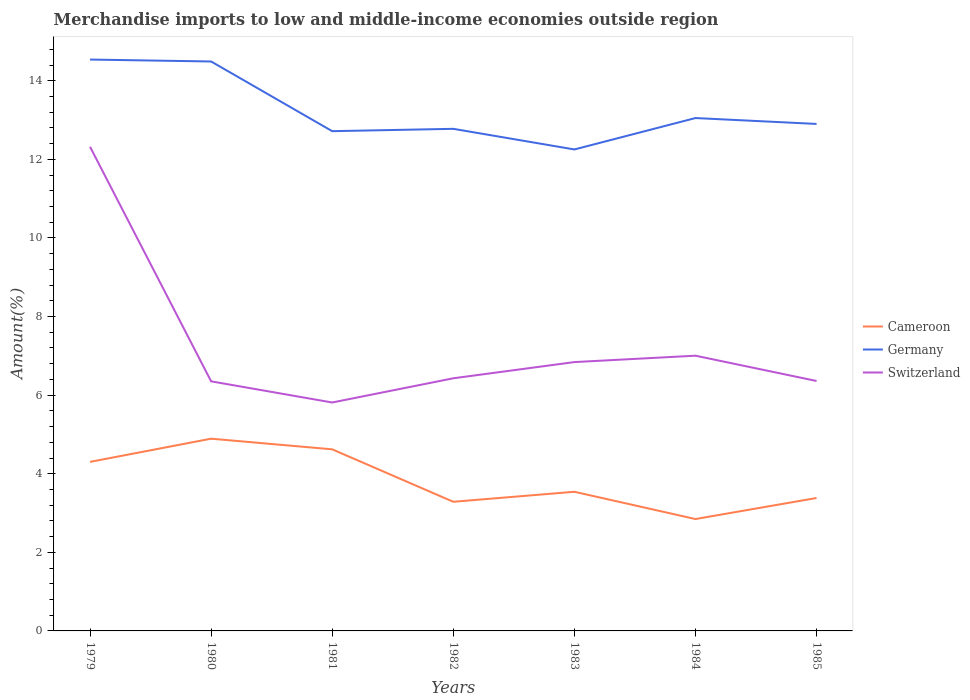Across all years, what is the maximum percentage of amount earned from merchandise imports in Switzerland?
Provide a short and direct response. 5.81. What is the total percentage of amount earned from merchandise imports in Germany in the graph?
Offer a terse response. -0.27. What is the difference between the highest and the second highest percentage of amount earned from merchandise imports in Switzerland?
Your answer should be very brief. 6.51. Is the percentage of amount earned from merchandise imports in Germany strictly greater than the percentage of amount earned from merchandise imports in Cameroon over the years?
Provide a short and direct response. No. What is the difference between two consecutive major ticks on the Y-axis?
Provide a short and direct response. 2. Does the graph contain grids?
Ensure brevity in your answer.  No. Where does the legend appear in the graph?
Keep it short and to the point. Center right. How are the legend labels stacked?
Your answer should be very brief. Vertical. What is the title of the graph?
Keep it short and to the point. Merchandise imports to low and middle-income economies outside region. What is the label or title of the X-axis?
Offer a very short reply. Years. What is the label or title of the Y-axis?
Ensure brevity in your answer.  Amount(%). What is the Amount(%) of Cameroon in 1979?
Ensure brevity in your answer.  4.3. What is the Amount(%) in Germany in 1979?
Make the answer very short. 14.54. What is the Amount(%) of Switzerland in 1979?
Keep it short and to the point. 12.32. What is the Amount(%) in Cameroon in 1980?
Ensure brevity in your answer.  4.89. What is the Amount(%) of Germany in 1980?
Ensure brevity in your answer.  14.49. What is the Amount(%) of Switzerland in 1980?
Offer a terse response. 6.35. What is the Amount(%) in Cameroon in 1981?
Your answer should be very brief. 4.62. What is the Amount(%) of Germany in 1981?
Your response must be concise. 12.72. What is the Amount(%) of Switzerland in 1981?
Your answer should be very brief. 5.81. What is the Amount(%) of Cameroon in 1982?
Make the answer very short. 3.29. What is the Amount(%) of Germany in 1982?
Your answer should be very brief. 12.78. What is the Amount(%) of Switzerland in 1982?
Your answer should be compact. 6.43. What is the Amount(%) in Cameroon in 1983?
Provide a short and direct response. 3.54. What is the Amount(%) of Germany in 1983?
Ensure brevity in your answer.  12.25. What is the Amount(%) of Switzerland in 1983?
Your answer should be very brief. 6.84. What is the Amount(%) in Cameroon in 1984?
Make the answer very short. 2.85. What is the Amount(%) of Germany in 1984?
Your response must be concise. 13.05. What is the Amount(%) in Switzerland in 1984?
Your response must be concise. 7. What is the Amount(%) of Cameroon in 1985?
Provide a short and direct response. 3.38. What is the Amount(%) of Germany in 1985?
Offer a terse response. 12.9. What is the Amount(%) in Switzerland in 1985?
Offer a terse response. 6.36. Across all years, what is the maximum Amount(%) in Cameroon?
Give a very brief answer. 4.89. Across all years, what is the maximum Amount(%) of Germany?
Your response must be concise. 14.54. Across all years, what is the maximum Amount(%) in Switzerland?
Give a very brief answer. 12.32. Across all years, what is the minimum Amount(%) of Cameroon?
Offer a terse response. 2.85. Across all years, what is the minimum Amount(%) of Germany?
Ensure brevity in your answer.  12.25. Across all years, what is the minimum Amount(%) of Switzerland?
Provide a succinct answer. 5.81. What is the total Amount(%) in Cameroon in the graph?
Keep it short and to the point. 26.87. What is the total Amount(%) of Germany in the graph?
Your answer should be compact. 92.73. What is the total Amount(%) in Switzerland in the graph?
Your answer should be very brief. 51.12. What is the difference between the Amount(%) in Cameroon in 1979 and that in 1980?
Provide a succinct answer. -0.59. What is the difference between the Amount(%) in Germany in 1979 and that in 1980?
Your response must be concise. 0.05. What is the difference between the Amount(%) in Switzerland in 1979 and that in 1980?
Make the answer very short. 5.97. What is the difference between the Amount(%) of Cameroon in 1979 and that in 1981?
Keep it short and to the point. -0.32. What is the difference between the Amount(%) of Germany in 1979 and that in 1981?
Make the answer very short. 1.82. What is the difference between the Amount(%) of Switzerland in 1979 and that in 1981?
Give a very brief answer. 6.51. What is the difference between the Amount(%) in Cameroon in 1979 and that in 1982?
Offer a terse response. 1.02. What is the difference between the Amount(%) of Germany in 1979 and that in 1982?
Offer a terse response. 1.76. What is the difference between the Amount(%) in Switzerland in 1979 and that in 1982?
Provide a short and direct response. 5.89. What is the difference between the Amount(%) of Cameroon in 1979 and that in 1983?
Ensure brevity in your answer.  0.76. What is the difference between the Amount(%) in Germany in 1979 and that in 1983?
Make the answer very short. 2.29. What is the difference between the Amount(%) in Switzerland in 1979 and that in 1983?
Offer a very short reply. 5.48. What is the difference between the Amount(%) in Cameroon in 1979 and that in 1984?
Your answer should be compact. 1.45. What is the difference between the Amount(%) in Germany in 1979 and that in 1984?
Offer a very short reply. 1.49. What is the difference between the Amount(%) in Switzerland in 1979 and that in 1984?
Offer a terse response. 5.32. What is the difference between the Amount(%) of Cameroon in 1979 and that in 1985?
Keep it short and to the point. 0.92. What is the difference between the Amount(%) in Germany in 1979 and that in 1985?
Your answer should be very brief. 1.64. What is the difference between the Amount(%) in Switzerland in 1979 and that in 1985?
Your answer should be compact. 5.96. What is the difference between the Amount(%) of Cameroon in 1980 and that in 1981?
Ensure brevity in your answer.  0.27. What is the difference between the Amount(%) in Germany in 1980 and that in 1981?
Keep it short and to the point. 1.77. What is the difference between the Amount(%) in Switzerland in 1980 and that in 1981?
Your answer should be very brief. 0.54. What is the difference between the Amount(%) of Cameroon in 1980 and that in 1982?
Your answer should be compact. 1.61. What is the difference between the Amount(%) of Germany in 1980 and that in 1982?
Provide a short and direct response. 1.71. What is the difference between the Amount(%) of Switzerland in 1980 and that in 1982?
Your response must be concise. -0.08. What is the difference between the Amount(%) in Cameroon in 1980 and that in 1983?
Ensure brevity in your answer.  1.35. What is the difference between the Amount(%) of Germany in 1980 and that in 1983?
Your answer should be very brief. 2.24. What is the difference between the Amount(%) of Switzerland in 1980 and that in 1983?
Offer a very short reply. -0.49. What is the difference between the Amount(%) of Cameroon in 1980 and that in 1984?
Provide a succinct answer. 2.04. What is the difference between the Amount(%) of Germany in 1980 and that in 1984?
Your answer should be compact. 1.44. What is the difference between the Amount(%) in Switzerland in 1980 and that in 1984?
Give a very brief answer. -0.65. What is the difference between the Amount(%) in Cameroon in 1980 and that in 1985?
Keep it short and to the point. 1.51. What is the difference between the Amount(%) of Germany in 1980 and that in 1985?
Your answer should be very brief. 1.59. What is the difference between the Amount(%) of Switzerland in 1980 and that in 1985?
Give a very brief answer. -0.01. What is the difference between the Amount(%) of Cameroon in 1981 and that in 1982?
Make the answer very short. 1.33. What is the difference between the Amount(%) in Germany in 1981 and that in 1982?
Your answer should be compact. -0.06. What is the difference between the Amount(%) of Switzerland in 1981 and that in 1982?
Keep it short and to the point. -0.62. What is the difference between the Amount(%) in Cameroon in 1981 and that in 1983?
Make the answer very short. 1.08. What is the difference between the Amount(%) of Germany in 1981 and that in 1983?
Provide a succinct answer. 0.47. What is the difference between the Amount(%) of Switzerland in 1981 and that in 1983?
Your response must be concise. -1.03. What is the difference between the Amount(%) in Cameroon in 1981 and that in 1984?
Offer a terse response. 1.77. What is the difference between the Amount(%) in Germany in 1981 and that in 1984?
Your answer should be compact. -0.33. What is the difference between the Amount(%) of Switzerland in 1981 and that in 1984?
Offer a very short reply. -1.19. What is the difference between the Amount(%) in Cameroon in 1981 and that in 1985?
Provide a succinct answer. 1.24. What is the difference between the Amount(%) of Germany in 1981 and that in 1985?
Your response must be concise. -0.18. What is the difference between the Amount(%) of Switzerland in 1981 and that in 1985?
Offer a terse response. -0.55. What is the difference between the Amount(%) of Cameroon in 1982 and that in 1983?
Your answer should be very brief. -0.25. What is the difference between the Amount(%) in Germany in 1982 and that in 1983?
Your answer should be very brief. 0.52. What is the difference between the Amount(%) of Switzerland in 1982 and that in 1983?
Ensure brevity in your answer.  -0.41. What is the difference between the Amount(%) of Cameroon in 1982 and that in 1984?
Your answer should be very brief. 0.44. What is the difference between the Amount(%) of Germany in 1982 and that in 1984?
Your answer should be compact. -0.27. What is the difference between the Amount(%) of Switzerland in 1982 and that in 1984?
Keep it short and to the point. -0.57. What is the difference between the Amount(%) of Cameroon in 1982 and that in 1985?
Ensure brevity in your answer.  -0.1. What is the difference between the Amount(%) in Germany in 1982 and that in 1985?
Your answer should be compact. -0.12. What is the difference between the Amount(%) in Switzerland in 1982 and that in 1985?
Ensure brevity in your answer.  0.07. What is the difference between the Amount(%) in Cameroon in 1983 and that in 1984?
Offer a terse response. 0.69. What is the difference between the Amount(%) in Germany in 1983 and that in 1984?
Offer a very short reply. -0.8. What is the difference between the Amount(%) of Switzerland in 1983 and that in 1984?
Give a very brief answer. -0.16. What is the difference between the Amount(%) in Cameroon in 1983 and that in 1985?
Offer a very short reply. 0.16. What is the difference between the Amount(%) of Germany in 1983 and that in 1985?
Offer a very short reply. -0.65. What is the difference between the Amount(%) of Switzerland in 1983 and that in 1985?
Ensure brevity in your answer.  0.48. What is the difference between the Amount(%) in Cameroon in 1984 and that in 1985?
Provide a succinct answer. -0.54. What is the difference between the Amount(%) of Germany in 1984 and that in 1985?
Provide a succinct answer. 0.15. What is the difference between the Amount(%) of Switzerland in 1984 and that in 1985?
Provide a short and direct response. 0.64. What is the difference between the Amount(%) of Cameroon in 1979 and the Amount(%) of Germany in 1980?
Keep it short and to the point. -10.19. What is the difference between the Amount(%) of Cameroon in 1979 and the Amount(%) of Switzerland in 1980?
Provide a short and direct response. -2.05. What is the difference between the Amount(%) of Germany in 1979 and the Amount(%) of Switzerland in 1980?
Make the answer very short. 8.19. What is the difference between the Amount(%) of Cameroon in 1979 and the Amount(%) of Germany in 1981?
Keep it short and to the point. -8.42. What is the difference between the Amount(%) in Cameroon in 1979 and the Amount(%) in Switzerland in 1981?
Offer a terse response. -1.51. What is the difference between the Amount(%) of Germany in 1979 and the Amount(%) of Switzerland in 1981?
Give a very brief answer. 8.73. What is the difference between the Amount(%) of Cameroon in 1979 and the Amount(%) of Germany in 1982?
Keep it short and to the point. -8.47. What is the difference between the Amount(%) in Cameroon in 1979 and the Amount(%) in Switzerland in 1982?
Your response must be concise. -2.13. What is the difference between the Amount(%) in Germany in 1979 and the Amount(%) in Switzerland in 1982?
Give a very brief answer. 8.11. What is the difference between the Amount(%) in Cameroon in 1979 and the Amount(%) in Germany in 1983?
Provide a succinct answer. -7.95. What is the difference between the Amount(%) of Cameroon in 1979 and the Amount(%) of Switzerland in 1983?
Offer a very short reply. -2.54. What is the difference between the Amount(%) in Germany in 1979 and the Amount(%) in Switzerland in 1983?
Ensure brevity in your answer.  7.7. What is the difference between the Amount(%) in Cameroon in 1979 and the Amount(%) in Germany in 1984?
Offer a very short reply. -8.75. What is the difference between the Amount(%) in Cameroon in 1979 and the Amount(%) in Switzerland in 1984?
Your answer should be very brief. -2.7. What is the difference between the Amount(%) of Germany in 1979 and the Amount(%) of Switzerland in 1984?
Provide a succinct answer. 7.54. What is the difference between the Amount(%) of Cameroon in 1979 and the Amount(%) of Germany in 1985?
Ensure brevity in your answer.  -8.6. What is the difference between the Amount(%) of Cameroon in 1979 and the Amount(%) of Switzerland in 1985?
Offer a very short reply. -2.06. What is the difference between the Amount(%) in Germany in 1979 and the Amount(%) in Switzerland in 1985?
Your answer should be compact. 8.18. What is the difference between the Amount(%) in Cameroon in 1980 and the Amount(%) in Germany in 1981?
Keep it short and to the point. -7.83. What is the difference between the Amount(%) of Cameroon in 1980 and the Amount(%) of Switzerland in 1981?
Provide a short and direct response. -0.92. What is the difference between the Amount(%) in Germany in 1980 and the Amount(%) in Switzerland in 1981?
Provide a short and direct response. 8.68. What is the difference between the Amount(%) of Cameroon in 1980 and the Amount(%) of Germany in 1982?
Provide a short and direct response. -7.89. What is the difference between the Amount(%) of Cameroon in 1980 and the Amount(%) of Switzerland in 1982?
Provide a short and direct response. -1.54. What is the difference between the Amount(%) of Germany in 1980 and the Amount(%) of Switzerland in 1982?
Make the answer very short. 8.06. What is the difference between the Amount(%) of Cameroon in 1980 and the Amount(%) of Germany in 1983?
Your answer should be very brief. -7.36. What is the difference between the Amount(%) of Cameroon in 1980 and the Amount(%) of Switzerland in 1983?
Your answer should be very brief. -1.95. What is the difference between the Amount(%) of Germany in 1980 and the Amount(%) of Switzerland in 1983?
Keep it short and to the point. 7.65. What is the difference between the Amount(%) of Cameroon in 1980 and the Amount(%) of Germany in 1984?
Keep it short and to the point. -8.16. What is the difference between the Amount(%) in Cameroon in 1980 and the Amount(%) in Switzerland in 1984?
Give a very brief answer. -2.11. What is the difference between the Amount(%) of Germany in 1980 and the Amount(%) of Switzerland in 1984?
Ensure brevity in your answer.  7.49. What is the difference between the Amount(%) in Cameroon in 1980 and the Amount(%) in Germany in 1985?
Keep it short and to the point. -8.01. What is the difference between the Amount(%) of Cameroon in 1980 and the Amount(%) of Switzerland in 1985?
Your answer should be very brief. -1.47. What is the difference between the Amount(%) in Germany in 1980 and the Amount(%) in Switzerland in 1985?
Your response must be concise. 8.13. What is the difference between the Amount(%) of Cameroon in 1981 and the Amount(%) of Germany in 1982?
Offer a very short reply. -8.16. What is the difference between the Amount(%) in Cameroon in 1981 and the Amount(%) in Switzerland in 1982?
Your answer should be compact. -1.81. What is the difference between the Amount(%) in Germany in 1981 and the Amount(%) in Switzerland in 1982?
Give a very brief answer. 6.29. What is the difference between the Amount(%) of Cameroon in 1981 and the Amount(%) of Germany in 1983?
Provide a short and direct response. -7.63. What is the difference between the Amount(%) in Cameroon in 1981 and the Amount(%) in Switzerland in 1983?
Offer a terse response. -2.22. What is the difference between the Amount(%) of Germany in 1981 and the Amount(%) of Switzerland in 1983?
Make the answer very short. 5.88. What is the difference between the Amount(%) in Cameroon in 1981 and the Amount(%) in Germany in 1984?
Provide a short and direct response. -8.43. What is the difference between the Amount(%) in Cameroon in 1981 and the Amount(%) in Switzerland in 1984?
Offer a very short reply. -2.38. What is the difference between the Amount(%) in Germany in 1981 and the Amount(%) in Switzerland in 1984?
Provide a short and direct response. 5.71. What is the difference between the Amount(%) of Cameroon in 1981 and the Amount(%) of Germany in 1985?
Offer a terse response. -8.28. What is the difference between the Amount(%) of Cameroon in 1981 and the Amount(%) of Switzerland in 1985?
Offer a very short reply. -1.74. What is the difference between the Amount(%) of Germany in 1981 and the Amount(%) of Switzerland in 1985?
Provide a succinct answer. 6.36. What is the difference between the Amount(%) of Cameroon in 1982 and the Amount(%) of Germany in 1983?
Provide a succinct answer. -8.97. What is the difference between the Amount(%) of Cameroon in 1982 and the Amount(%) of Switzerland in 1983?
Provide a succinct answer. -3.56. What is the difference between the Amount(%) of Germany in 1982 and the Amount(%) of Switzerland in 1983?
Offer a very short reply. 5.94. What is the difference between the Amount(%) of Cameroon in 1982 and the Amount(%) of Germany in 1984?
Ensure brevity in your answer.  -9.77. What is the difference between the Amount(%) of Cameroon in 1982 and the Amount(%) of Switzerland in 1984?
Keep it short and to the point. -3.72. What is the difference between the Amount(%) of Germany in 1982 and the Amount(%) of Switzerland in 1984?
Your answer should be compact. 5.77. What is the difference between the Amount(%) of Cameroon in 1982 and the Amount(%) of Germany in 1985?
Your answer should be compact. -9.62. What is the difference between the Amount(%) in Cameroon in 1982 and the Amount(%) in Switzerland in 1985?
Keep it short and to the point. -3.07. What is the difference between the Amount(%) of Germany in 1982 and the Amount(%) of Switzerland in 1985?
Provide a short and direct response. 6.42. What is the difference between the Amount(%) in Cameroon in 1983 and the Amount(%) in Germany in 1984?
Offer a terse response. -9.51. What is the difference between the Amount(%) in Cameroon in 1983 and the Amount(%) in Switzerland in 1984?
Your answer should be compact. -3.46. What is the difference between the Amount(%) of Germany in 1983 and the Amount(%) of Switzerland in 1984?
Offer a very short reply. 5.25. What is the difference between the Amount(%) of Cameroon in 1983 and the Amount(%) of Germany in 1985?
Keep it short and to the point. -9.36. What is the difference between the Amount(%) of Cameroon in 1983 and the Amount(%) of Switzerland in 1985?
Your answer should be compact. -2.82. What is the difference between the Amount(%) of Germany in 1983 and the Amount(%) of Switzerland in 1985?
Offer a terse response. 5.89. What is the difference between the Amount(%) of Cameroon in 1984 and the Amount(%) of Germany in 1985?
Keep it short and to the point. -10.05. What is the difference between the Amount(%) in Cameroon in 1984 and the Amount(%) in Switzerland in 1985?
Keep it short and to the point. -3.51. What is the difference between the Amount(%) in Germany in 1984 and the Amount(%) in Switzerland in 1985?
Ensure brevity in your answer.  6.69. What is the average Amount(%) of Cameroon per year?
Your answer should be compact. 3.84. What is the average Amount(%) in Germany per year?
Your answer should be compact. 13.25. What is the average Amount(%) in Switzerland per year?
Provide a succinct answer. 7.3. In the year 1979, what is the difference between the Amount(%) in Cameroon and Amount(%) in Germany?
Your response must be concise. -10.24. In the year 1979, what is the difference between the Amount(%) of Cameroon and Amount(%) of Switzerland?
Make the answer very short. -8.02. In the year 1979, what is the difference between the Amount(%) of Germany and Amount(%) of Switzerland?
Keep it short and to the point. 2.22. In the year 1980, what is the difference between the Amount(%) in Cameroon and Amount(%) in Germany?
Your response must be concise. -9.6. In the year 1980, what is the difference between the Amount(%) of Cameroon and Amount(%) of Switzerland?
Make the answer very short. -1.46. In the year 1980, what is the difference between the Amount(%) in Germany and Amount(%) in Switzerland?
Give a very brief answer. 8.14. In the year 1981, what is the difference between the Amount(%) of Cameroon and Amount(%) of Germany?
Your answer should be very brief. -8.1. In the year 1981, what is the difference between the Amount(%) in Cameroon and Amount(%) in Switzerland?
Provide a short and direct response. -1.19. In the year 1981, what is the difference between the Amount(%) in Germany and Amount(%) in Switzerland?
Ensure brevity in your answer.  6.9. In the year 1982, what is the difference between the Amount(%) of Cameroon and Amount(%) of Germany?
Your response must be concise. -9.49. In the year 1982, what is the difference between the Amount(%) of Cameroon and Amount(%) of Switzerland?
Make the answer very short. -3.14. In the year 1982, what is the difference between the Amount(%) in Germany and Amount(%) in Switzerland?
Your answer should be very brief. 6.35. In the year 1983, what is the difference between the Amount(%) in Cameroon and Amount(%) in Germany?
Offer a terse response. -8.71. In the year 1983, what is the difference between the Amount(%) in Cameroon and Amount(%) in Switzerland?
Offer a terse response. -3.3. In the year 1983, what is the difference between the Amount(%) of Germany and Amount(%) of Switzerland?
Offer a very short reply. 5.41. In the year 1984, what is the difference between the Amount(%) in Cameroon and Amount(%) in Germany?
Give a very brief answer. -10.2. In the year 1984, what is the difference between the Amount(%) in Cameroon and Amount(%) in Switzerland?
Keep it short and to the point. -4.16. In the year 1984, what is the difference between the Amount(%) of Germany and Amount(%) of Switzerland?
Your answer should be compact. 6.05. In the year 1985, what is the difference between the Amount(%) in Cameroon and Amount(%) in Germany?
Provide a succinct answer. -9.52. In the year 1985, what is the difference between the Amount(%) of Cameroon and Amount(%) of Switzerland?
Offer a terse response. -2.98. In the year 1985, what is the difference between the Amount(%) of Germany and Amount(%) of Switzerland?
Provide a succinct answer. 6.54. What is the ratio of the Amount(%) in Cameroon in 1979 to that in 1980?
Make the answer very short. 0.88. What is the ratio of the Amount(%) of Switzerland in 1979 to that in 1980?
Make the answer very short. 1.94. What is the ratio of the Amount(%) in Cameroon in 1979 to that in 1981?
Give a very brief answer. 0.93. What is the ratio of the Amount(%) in Germany in 1979 to that in 1981?
Offer a very short reply. 1.14. What is the ratio of the Amount(%) of Switzerland in 1979 to that in 1981?
Your answer should be compact. 2.12. What is the ratio of the Amount(%) of Cameroon in 1979 to that in 1982?
Keep it short and to the point. 1.31. What is the ratio of the Amount(%) in Germany in 1979 to that in 1982?
Ensure brevity in your answer.  1.14. What is the ratio of the Amount(%) of Switzerland in 1979 to that in 1982?
Your answer should be very brief. 1.92. What is the ratio of the Amount(%) of Cameroon in 1979 to that in 1983?
Offer a terse response. 1.21. What is the ratio of the Amount(%) of Germany in 1979 to that in 1983?
Give a very brief answer. 1.19. What is the ratio of the Amount(%) in Switzerland in 1979 to that in 1983?
Provide a succinct answer. 1.8. What is the ratio of the Amount(%) in Cameroon in 1979 to that in 1984?
Offer a terse response. 1.51. What is the ratio of the Amount(%) of Germany in 1979 to that in 1984?
Make the answer very short. 1.11. What is the ratio of the Amount(%) of Switzerland in 1979 to that in 1984?
Your answer should be very brief. 1.76. What is the ratio of the Amount(%) of Cameroon in 1979 to that in 1985?
Offer a very short reply. 1.27. What is the ratio of the Amount(%) of Germany in 1979 to that in 1985?
Your answer should be very brief. 1.13. What is the ratio of the Amount(%) of Switzerland in 1979 to that in 1985?
Your answer should be very brief. 1.94. What is the ratio of the Amount(%) of Cameroon in 1980 to that in 1981?
Your answer should be compact. 1.06. What is the ratio of the Amount(%) of Germany in 1980 to that in 1981?
Keep it short and to the point. 1.14. What is the ratio of the Amount(%) in Switzerland in 1980 to that in 1981?
Give a very brief answer. 1.09. What is the ratio of the Amount(%) in Cameroon in 1980 to that in 1982?
Your answer should be very brief. 1.49. What is the ratio of the Amount(%) of Germany in 1980 to that in 1982?
Provide a short and direct response. 1.13. What is the ratio of the Amount(%) in Switzerland in 1980 to that in 1982?
Offer a very short reply. 0.99. What is the ratio of the Amount(%) in Cameroon in 1980 to that in 1983?
Provide a succinct answer. 1.38. What is the ratio of the Amount(%) in Germany in 1980 to that in 1983?
Offer a terse response. 1.18. What is the ratio of the Amount(%) of Switzerland in 1980 to that in 1983?
Offer a terse response. 0.93. What is the ratio of the Amount(%) in Cameroon in 1980 to that in 1984?
Give a very brief answer. 1.72. What is the ratio of the Amount(%) in Germany in 1980 to that in 1984?
Provide a succinct answer. 1.11. What is the ratio of the Amount(%) in Switzerland in 1980 to that in 1984?
Keep it short and to the point. 0.91. What is the ratio of the Amount(%) in Cameroon in 1980 to that in 1985?
Ensure brevity in your answer.  1.45. What is the ratio of the Amount(%) of Germany in 1980 to that in 1985?
Your answer should be very brief. 1.12. What is the ratio of the Amount(%) of Switzerland in 1980 to that in 1985?
Your response must be concise. 1. What is the ratio of the Amount(%) in Cameroon in 1981 to that in 1982?
Keep it short and to the point. 1.41. What is the ratio of the Amount(%) in Switzerland in 1981 to that in 1982?
Your answer should be very brief. 0.9. What is the ratio of the Amount(%) in Cameroon in 1981 to that in 1983?
Ensure brevity in your answer.  1.31. What is the ratio of the Amount(%) of Germany in 1981 to that in 1983?
Offer a very short reply. 1.04. What is the ratio of the Amount(%) in Switzerland in 1981 to that in 1983?
Offer a terse response. 0.85. What is the ratio of the Amount(%) in Cameroon in 1981 to that in 1984?
Your answer should be compact. 1.62. What is the ratio of the Amount(%) of Germany in 1981 to that in 1984?
Your answer should be very brief. 0.97. What is the ratio of the Amount(%) of Switzerland in 1981 to that in 1984?
Your answer should be very brief. 0.83. What is the ratio of the Amount(%) of Cameroon in 1981 to that in 1985?
Make the answer very short. 1.37. What is the ratio of the Amount(%) of Germany in 1981 to that in 1985?
Ensure brevity in your answer.  0.99. What is the ratio of the Amount(%) in Switzerland in 1981 to that in 1985?
Make the answer very short. 0.91. What is the ratio of the Amount(%) of Cameroon in 1982 to that in 1983?
Your answer should be compact. 0.93. What is the ratio of the Amount(%) in Germany in 1982 to that in 1983?
Your answer should be compact. 1.04. What is the ratio of the Amount(%) in Switzerland in 1982 to that in 1983?
Give a very brief answer. 0.94. What is the ratio of the Amount(%) in Cameroon in 1982 to that in 1984?
Provide a succinct answer. 1.15. What is the ratio of the Amount(%) in Switzerland in 1982 to that in 1984?
Offer a very short reply. 0.92. What is the ratio of the Amount(%) of Cameroon in 1982 to that in 1985?
Provide a short and direct response. 0.97. What is the ratio of the Amount(%) of Germany in 1982 to that in 1985?
Offer a very short reply. 0.99. What is the ratio of the Amount(%) of Switzerland in 1982 to that in 1985?
Provide a short and direct response. 1.01. What is the ratio of the Amount(%) in Cameroon in 1983 to that in 1984?
Make the answer very short. 1.24. What is the ratio of the Amount(%) in Germany in 1983 to that in 1984?
Make the answer very short. 0.94. What is the ratio of the Amount(%) in Switzerland in 1983 to that in 1984?
Give a very brief answer. 0.98. What is the ratio of the Amount(%) of Cameroon in 1983 to that in 1985?
Offer a very short reply. 1.05. What is the ratio of the Amount(%) in Germany in 1983 to that in 1985?
Make the answer very short. 0.95. What is the ratio of the Amount(%) in Switzerland in 1983 to that in 1985?
Provide a short and direct response. 1.08. What is the ratio of the Amount(%) in Cameroon in 1984 to that in 1985?
Your response must be concise. 0.84. What is the ratio of the Amount(%) of Germany in 1984 to that in 1985?
Your answer should be compact. 1.01. What is the ratio of the Amount(%) of Switzerland in 1984 to that in 1985?
Offer a terse response. 1.1. What is the difference between the highest and the second highest Amount(%) of Cameroon?
Offer a terse response. 0.27. What is the difference between the highest and the second highest Amount(%) of Germany?
Provide a short and direct response. 0.05. What is the difference between the highest and the second highest Amount(%) of Switzerland?
Provide a succinct answer. 5.32. What is the difference between the highest and the lowest Amount(%) in Cameroon?
Give a very brief answer. 2.04. What is the difference between the highest and the lowest Amount(%) in Germany?
Ensure brevity in your answer.  2.29. What is the difference between the highest and the lowest Amount(%) in Switzerland?
Offer a very short reply. 6.51. 